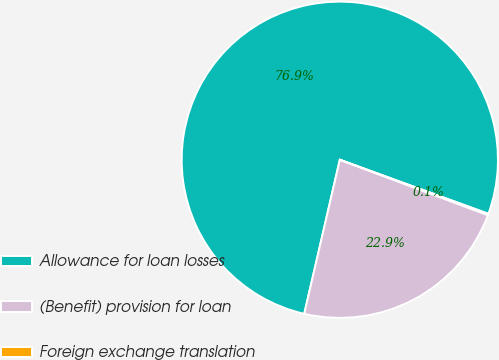Convert chart to OTSL. <chart><loc_0><loc_0><loc_500><loc_500><pie_chart><fcel>Allowance for loan losses<fcel>(Benefit) provision for loan<fcel>Foreign exchange translation<nl><fcel>76.94%<fcel>22.92%<fcel>0.14%<nl></chart> 